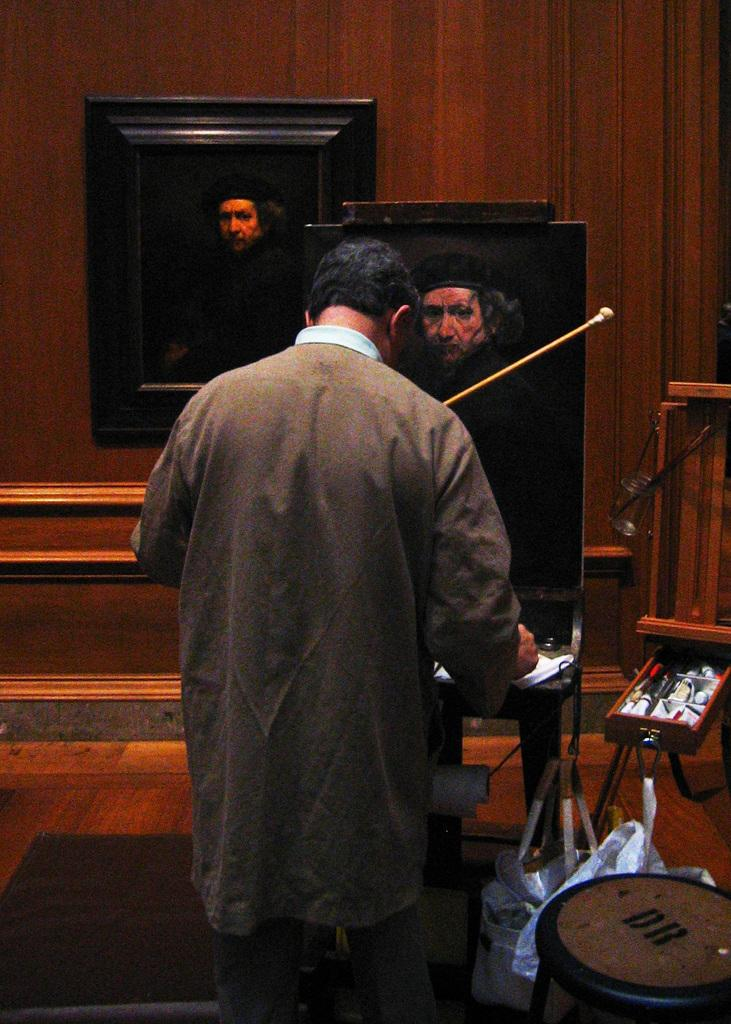What is the person in the image doing? The person is standing at a board in the image. What is located on the right side of the image? There is a stool and other objects on the right side of the image. What can be seen in the background of the image? There is a frame on the wall in the background of the image. What else is present in the image besides the person and the stool? There are bags and other objects visible in the image. What number is the coach wearing in the image? There is no coach or any reference to a number in the image. 